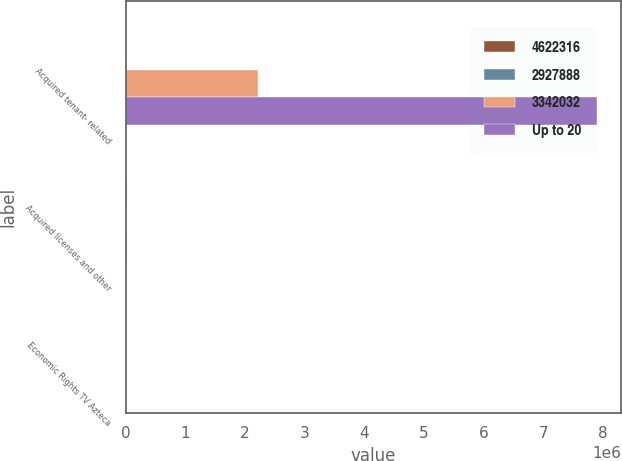Convert chart to OTSL. <chart><loc_0><loc_0><loc_500><loc_500><stacked_bar_chart><ecel><fcel>Acquired tenant- related<fcel>Acquired licenses and other<fcel>Economic Rights TV Azteca<nl><fcel>4622316<fcel>1520<fcel>320<fcel>70<nl><fcel>2927888<fcel>10974<fcel>28140<fcel>13893<nl><fcel>3342032<fcel>2.22412e+06<fcel>4827<fcel>10974<nl><fcel>Up to 20<fcel>7.90635e+06<fcel>23313<fcel>2919<nl></chart> 